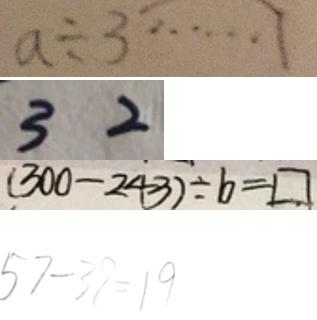<formula> <loc_0><loc_0><loc_500><loc_500>a \div 3 \cdots 1 
 3 2 
 ( 3 0 0 - 2 4 3 ) \div b = \square 
 5 7 - 3 7 = 1 9</formula> 